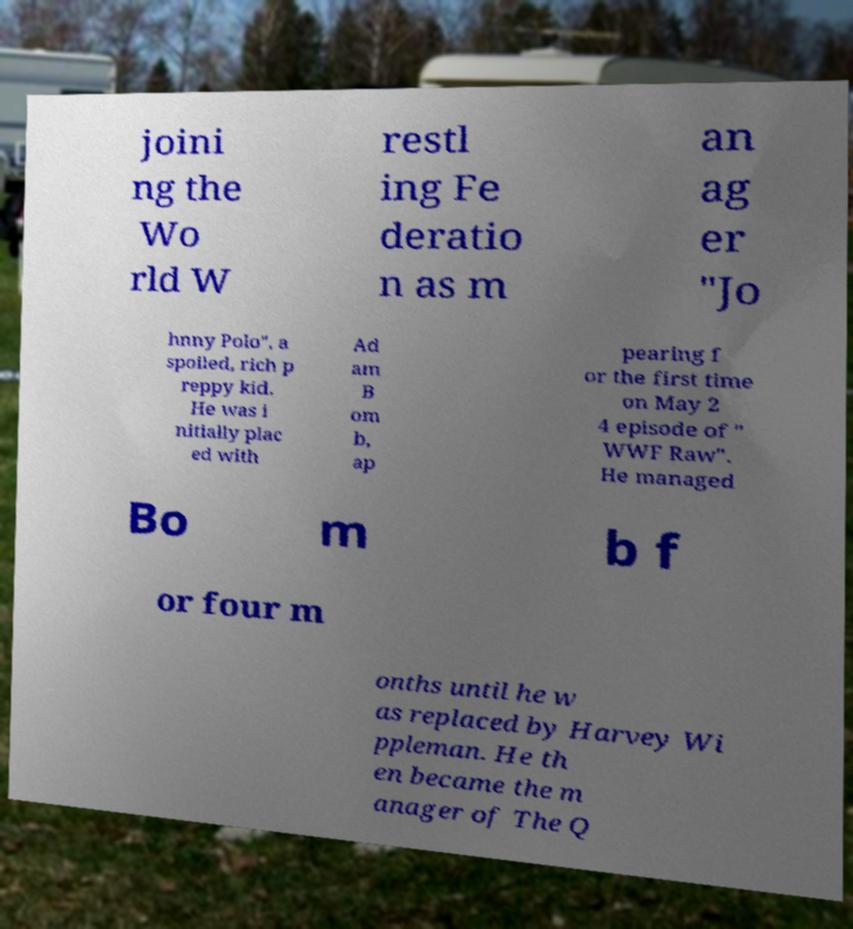There's text embedded in this image that I need extracted. Can you transcribe it verbatim? joini ng the Wo rld W restl ing Fe deratio n as m an ag er "Jo hnny Polo", a spoiled, rich p reppy kid. He was i nitially plac ed with Ad am B om b, ap pearing f or the first time on May 2 4 episode of " WWF Raw". He managed Bo m b f or four m onths until he w as replaced by Harvey Wi ppleman. He th en became the m anager of The Q 